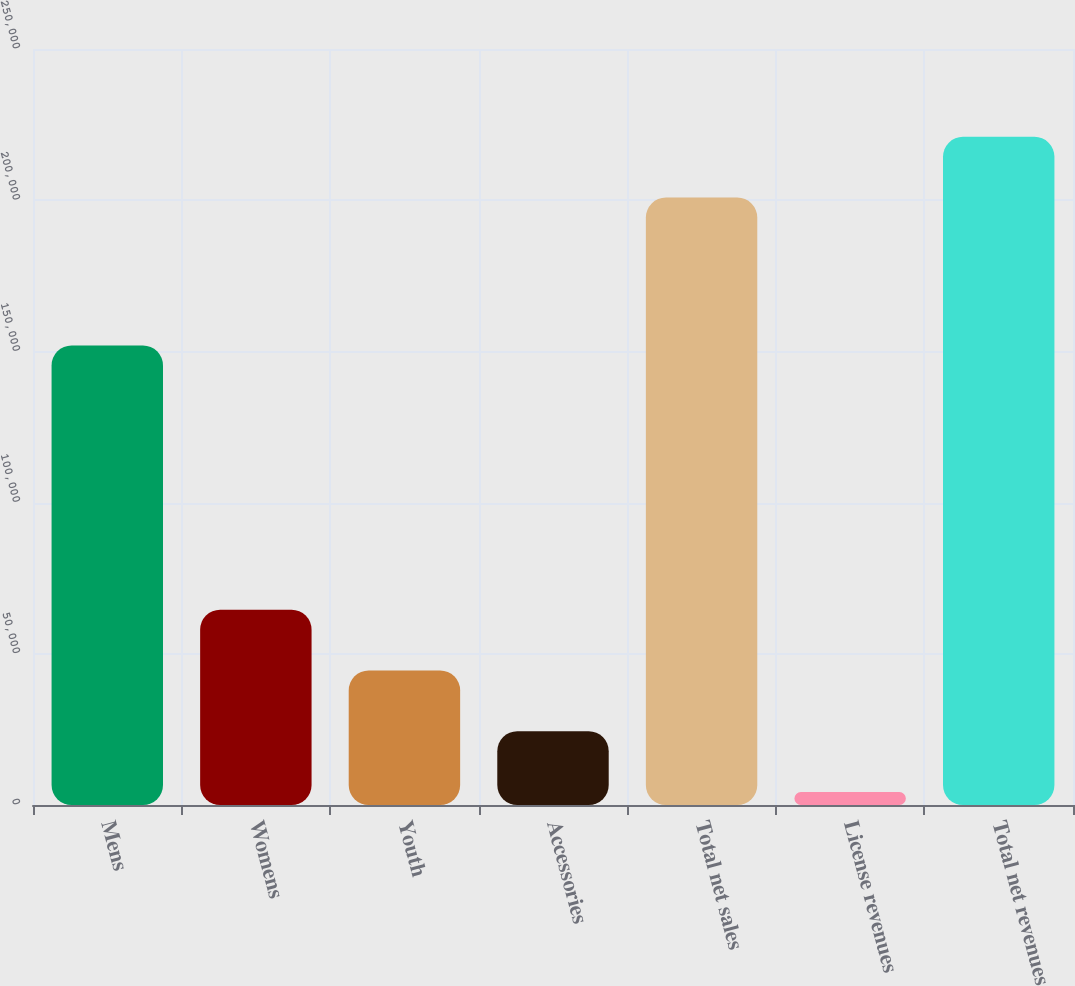Convert chart to OTSL. <chart><loc_0><loc_0><loc_500><loc_500><bar_chart><fcel>Mens<fcel>Womens<fcel>Youth<fcel>Accessories<fcel>Total net sales<fcel>License revenues<fcel>Total net revenues<nl><fcel>151962<fcel>64569.2<fcel>44481.8<fcel>24394.4<fcel>200874<fcel>4307<fcel>220961<nl></chart> 